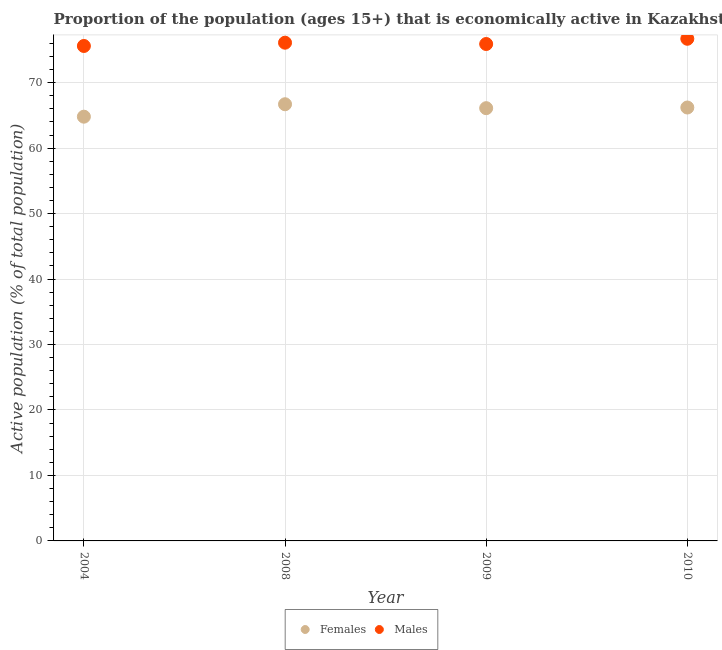What is the percentage of economically active male population in 2009?
Your response must be concise. 75.9. Across all years, what is the maximum percentage of economically active female population?
Ensure brevity in your answer.  66.7. Across all years, what is the minimum percentage of economically active female population?
Your answer should be very brief. 64.8. In which year was the percentage of economically active male population maximum?
Ensure brevity in your answer.  2010. In which year was the percentage of economically active male population minimum?
Ensure brevity in your answer.  2004. What is the total percentage of economically active male population in the graph?
Give a very brief answer. 304.3. What is the difference between the percentage of economically active female population in 2008 and that in 2010?
Your response must be concise. 0.5. What is the difference between the percentage of economically active female population in 2004 and the percentage of economically active male population in 2008?
Ensure brevity in your answer.  -11.3. What is the average percentage of economically active female population per year?
Keep it short and to the point. 65.95. In how many years, is the percentage of economically active female population greater than 56 %?
Your answer should be very brief. 4. What is the ratio of the percentage of economically active male population in 2009 to that in 2010?
Your answer should be very brief. 0.99. What is the difference between the highest and the second highest percentage of economically active male population?
Your answer should be very brief. 0.6. What is the difference between the highest and the lowest percentage of economically active male population?
Your answer should be compact. 1.1. In how many years, is the percentage of economically active female population greater than the average percentage of economically active female population taken over all years?
Your response must be concise. 3. Is the sum of the percentage of economically active female population in 2008 and 2009 greater than the maximum percentage of economically active male population across all years?
Offer a very short reply. Yes. How many dotlines are there?
Provide a short and direct response. 2. How many years are there in the graph?
Provide a short and direct response. 4. What is the difference between two consecutive major ticks on the Y-axis?
Provide a succinct answer. 10. Are the values on the major ticks of Y-axis written in scientific E-notation?
Keep it short and to the point. No. Does the graph contain any zero values?
Make the answer very short. No. Does the graph contain grids?
Provide a short and direct response. Yes. What is the title of the graph?
Your answer should be compact. Proportion of the population (ages 15+) that is economically active in Kazakhstan. Does "Female labor force" appear as one of the legend labels in the graph?
Offer a very short reply. No. What is the label or title of the Y-axis?
Offer a terse response. Active population (% of total population). What is the Active population (% of total population) of Females in 2004?
Your response must be concise. 64.8. What is the Active population (% of total population) in Males in 2004?
Offer a terse response. 75.6. What is the Active population (% of total population) of Females in 2008?
Give a very brief answer. 66.7. What is the Active population (% of total population) in Males in 2008?
Your response must be concise. 76.1. What is the Active population (% of total population) of Females in 2009?
Your answer should be compact. 66.1. What is the Active population (% of total population) in Males in 2009?
Make the answer very short. 75.9. What is the Active population (% of total population) of Females in 2010?
Offer a terse response. 66.2. What is the Active population (% of total population) in Males in 2010?
Your answer should be very brief. 76.7. Across all years, what is the maximum Active population (% of total population) in Females?
Provide a short and direct response. 66.7. Across all years, what is the maximum Active population (% of total population) in Males?
Your response must be concise. 76.7. Across all years, what is the minimum Active population (% of total population) of Females?
Provide a succinct answer. 64.8. Across all years, what is the minimum Active population (% of total population) of Males?
Ensure brevity in your answer.  75.6. What is the total Active population (% of total population) of Females in the graph?
Make the answer very short. 263.8. What is the total Active population (% of total population) of Males in the graph?
Ensure brevity in your answer.  304.3. What is the difference between the Active population (% of total population) of Females in 2004 and that in 2008?
Offer a terse response. -1.9. What is the difference between the Active population (% of total population) of Males in 2004 and that in 2008?
Your answer should be very brief. -0.5. What is the difference between the Active population (% of total population) in Females in 2004 and that in 2009?
Your answer should be very brief. -1.3. What is the difference between the Active population (% of total population) of Females in 2004 and that in 2010?
Your response must be concise. -1.4. What is the difference between the Active population (% of total population) in Males in 2004 and that in 2010?
Offer a terse response. -1.1. What is the difference between the Active population (% of total population) in Females in 2008 and that in 2009?
Give a very brief answer. 0.6. What is the difference between the Active population (% of total population) in Males in 2008 and that in 2009?
Keep it short and to the point. 0.2. What is the difference between the Active population (% of total population) in Females in 2008 and that in 2010?
Give a very brief answer. 0.5. What is the difference between the Active population (% of total population) in Males in 2008 and that in 2010?
Offer a very short reply. -0.6. What is the difference between the Active population (% of total population) in Males in 2009 and that in 2010?
Your answer should be compact. -0.8. What is the difference between the Active population (% of total population) of Females in 2004 and the Active population (% of total population) of Males in 2008?
Keep it short and to the point. -11.3. What is the difference between the Active population (% of total population) of Females in 2008 and the Active population (% of total population) of Males in 2009?
Provide a short and direct response. -9.2. What is the difference between the Active population (% of total population) in Females in 2008 and the Active population (% of total population) in Males in 2010?
Make the answer very short. -10. What is the difference between the Active population (% of total population) in Females in 2009 and the Active population (% of total population) in Males in 2010?
Make the answer very short. -10.6. What is the average Active population (% of total population) of Females per year?
Give a very brief answer. 65.95. What is the average Active population (% of total population) of Males per year?
Give a very brief answer. 76.08. In the year 2004, what is the difference between the Active population (% of total population) of Females and Active population (% of total population) of Males?
Offer a terse response. -10.8. In the year 2008, what is the difference between the Active population (% of total population) in Females and Active population (% of total population) in Males?
Ensure brevity in your answer.  -9.4. What is the ratio of the Active population (% of total population) in Females in 2004 to that in 2008?
Provide a short and direct response. 0.97. What is the ratio of the Active population (% of total population) in Females in 2004 to that in 2009?
Offer a terse response. 0.98. What is the ratio of the Active population (% of total population) in Males in 2004 to that in 2009?
Offer a terse response. 1. What is the ratio of the Active population (% of total population) in Females in 2004 to that in 2010?
Ensure brevity in your answer.  0.98. What is the ratio of the Active population (% of total population) in Males in 2004 to that in 2010?
Your answer should be very brief. 0.99. What is the ratio of the Active population (% of total population) of Females in 2008 to that in 2009?
Your answer should be compact. 1.01. What is the ratio of the Active population (% of total population) of Males in 2008 to that in 2009?
Your answer should be very brief. 1. What is the ratio of the Active population (% of total population) in Females in 2008 to that in 2010?
Offer a very short reply. 1.01. What is the ratio of the Active population (% of total population) in Males in 2009 to that in 2010?
Provide a short and direct response. 0.99. What is the difference between the highest and the second highest Active population (% of total population) of Females?
Offer a very short reply. 0.5. What is the difference between the highest and the second highest Active population (% of total population) of Males?
Provide a short and direct response. 0.6. What is the difference between the highest and the lowest Active population (% of total population) in Males?
Your response must be concise. 1.1. 